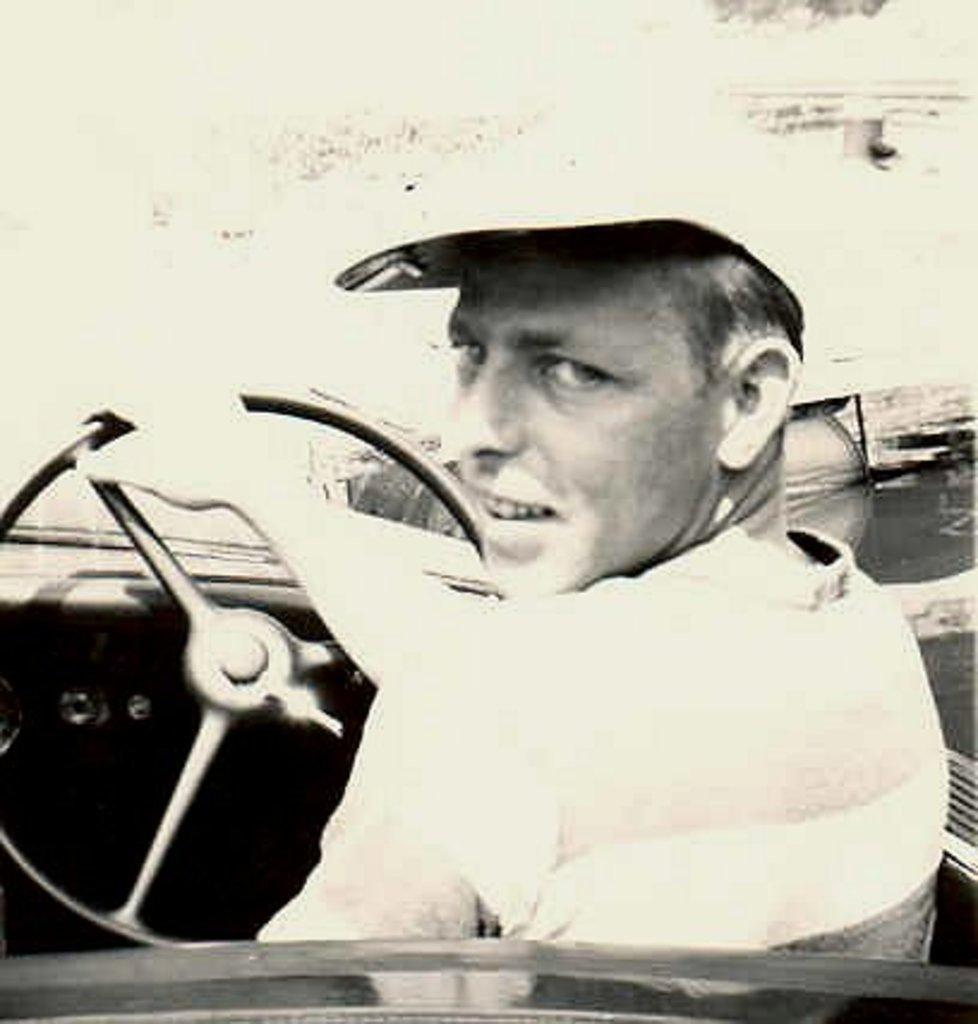Who is present in the image? There is a man in the image. Where is the man located? The man is inside a car. What is the man doing in the car? The man is holding a steering wheel. What is the man wearing on his head? The man is wearing a cap. What type of silk fabric is draped over the man's chin in the image? There is no silk fabric or any fabric draped over the man's chin in the image. 